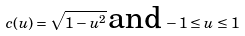<formula> <loc_0><loc_0><loc_500><loc_500>c ( u ) = \sqrt { 1 - u ^ { 2 } } \, \text {and} \, - 1 \leq u \leq 1</formula> 